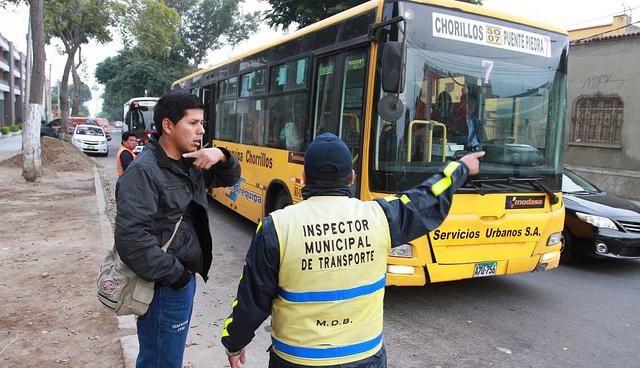Was this photo taken in the US?
Concise answer only. No. Is this an English speaking country?
Keep it brief. No. What is the man in yellow doing?
Quick response, please. Giving directions. 